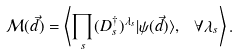Convert formula to latex. <formula><loc_0><loc_0><loc_500><loc_500>\mathcal { M } ( \vec { d } ) = \left \langle \prod _ { s } ( D _ { s } ^ { \dagger } ) ^ { \lambda _ { s } } | \psi ( \vec { d } ) \rangle , \ \forall \lambda _ { s } \right \rangle .</formula> 